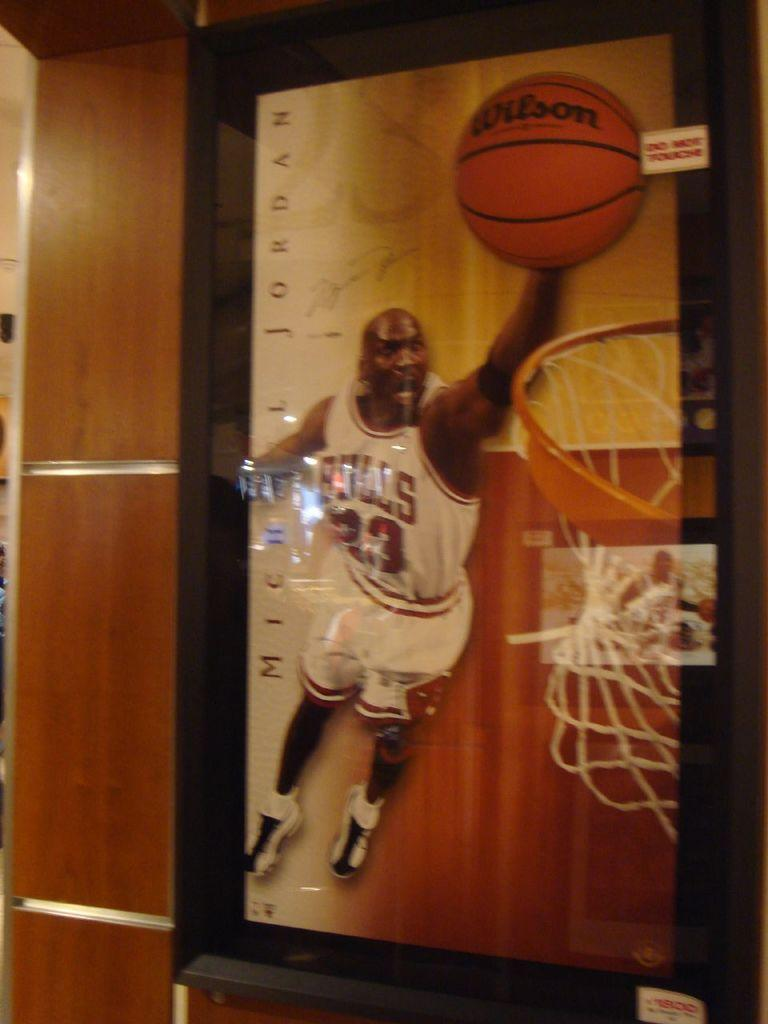<image>
Relay a brief, clear account of the picture shown. A poster of Michael Jordan making a basket with a Wilson basketball. 